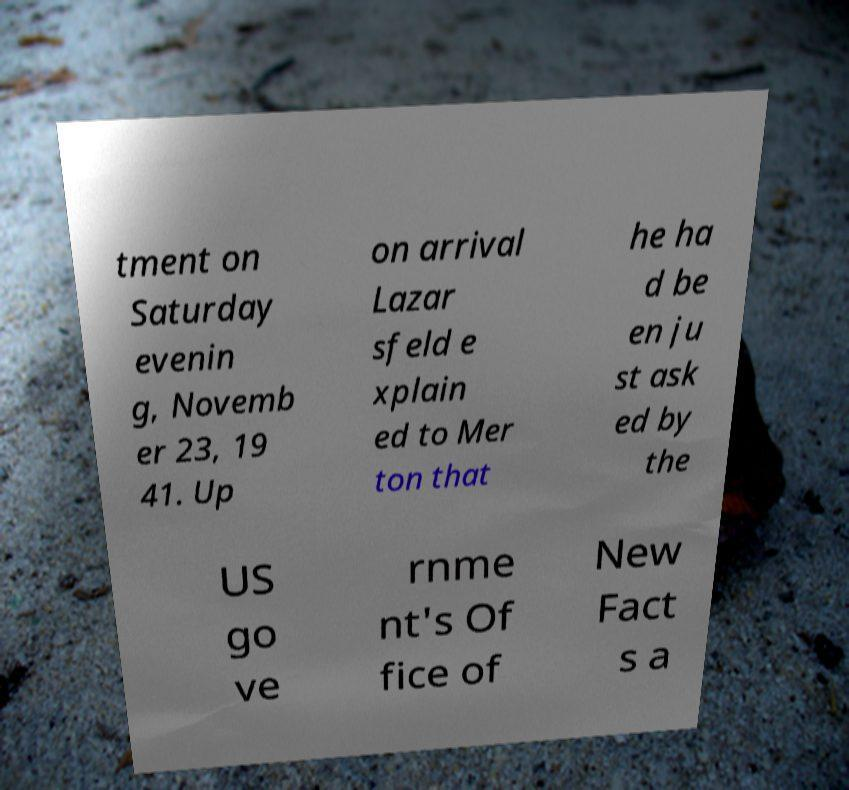I need the written content from this picture converted into text. Can you do that? tment on Saturday evenin g, Novemb er 23, 19 41. Up on arrival Lazar sfeld e xplain ed to Mer ton that he ha d be en ju st ask ed by the US go ve rnme nt's Of fice of New Fact s a 